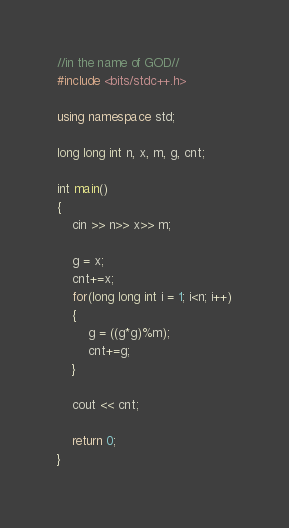Convert code to text. <code><loc_0><loc_0><loc_500><loc_500><_C++_>//in the name of GOD//
#include <bits/stdc++.h>

using namespace std;

long long int n, x, m, g, cnt;

int main()
{
	cin >> n>> x>> m;
	
	g = x;
	cnt+=x;
	for(long long int i = 1; i<n; i++)
	{
		g = ((g*g)%m);
		cnt+=g;
	}
	
	cout << cnt;
	
	return 0;
}</code> 